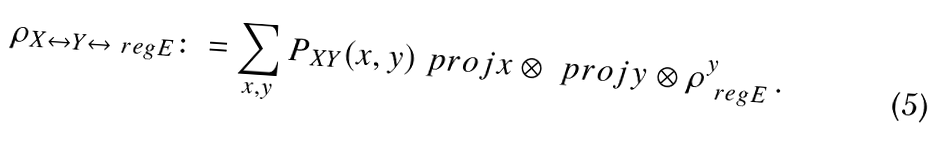<formula> <loc_0><loc_0><loc_500><loc_500>\rho _ { X \leftrightarrow Y \leftrightarrow \ r e g E } \colon = \sum _ { x , y } P _ { X Y } ( x , y ) \ p r o j { x } \otimes \ p r o j { y } \otimes \rho _ { \ r e g E } ^ { y } \, .</formula> 